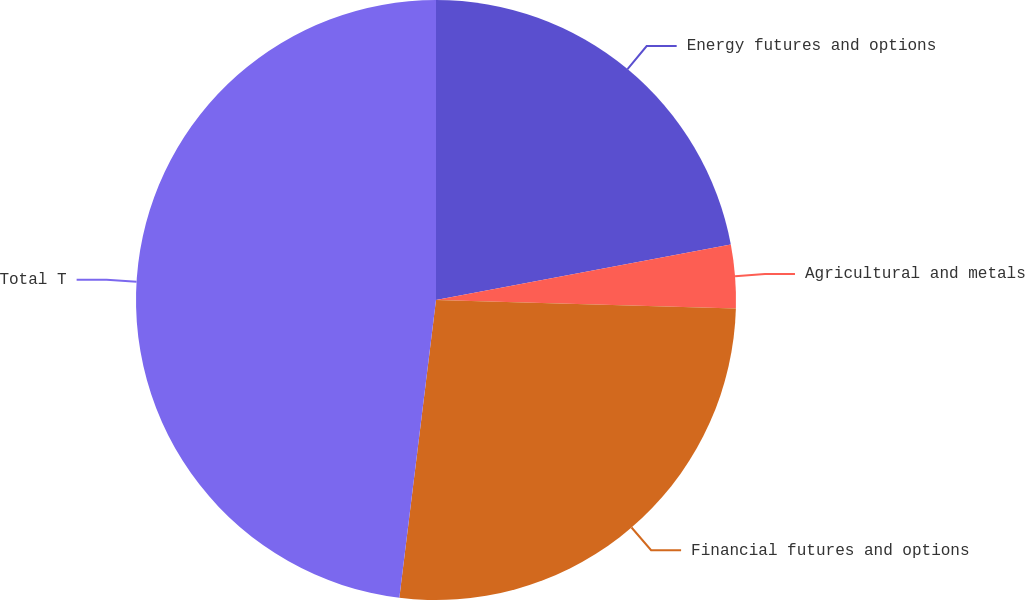<chart> <loc_0><loc_0><loc_500><loc_500><pie_chart><fcel>Energy futures and options<fcel>Agricultural and metals<fcel>Financial futures and options<fcel>Total T<nl><fcel>22.04%<fcel>3.41%<fcel>26.5%<fcel>48.05%<nl></chart> 